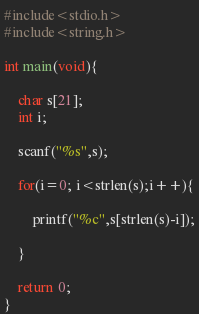<code> <loc_0><loc_0><loc_500><loc_500><_C_>#include<stdio.h>
#include<string.h>

int main(void){

	char s[21];
	int i;

	scanf("%s",s);

	for(i=0; i<strlen(s);i++){

		printf("%c",s[strlen(s)-i]);

	}

	return 0;
}</code> 